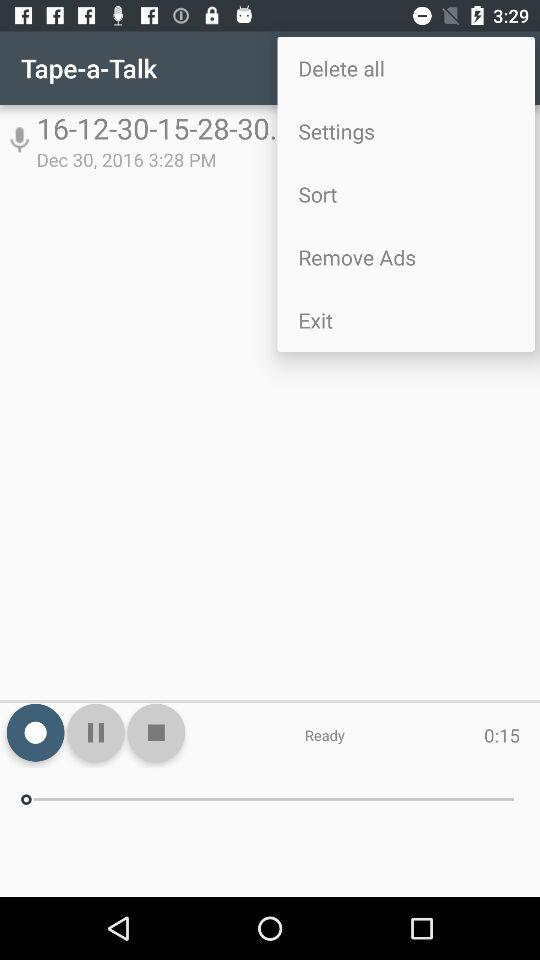What is the duration of the music? The duration of the music is 15 seconds. 